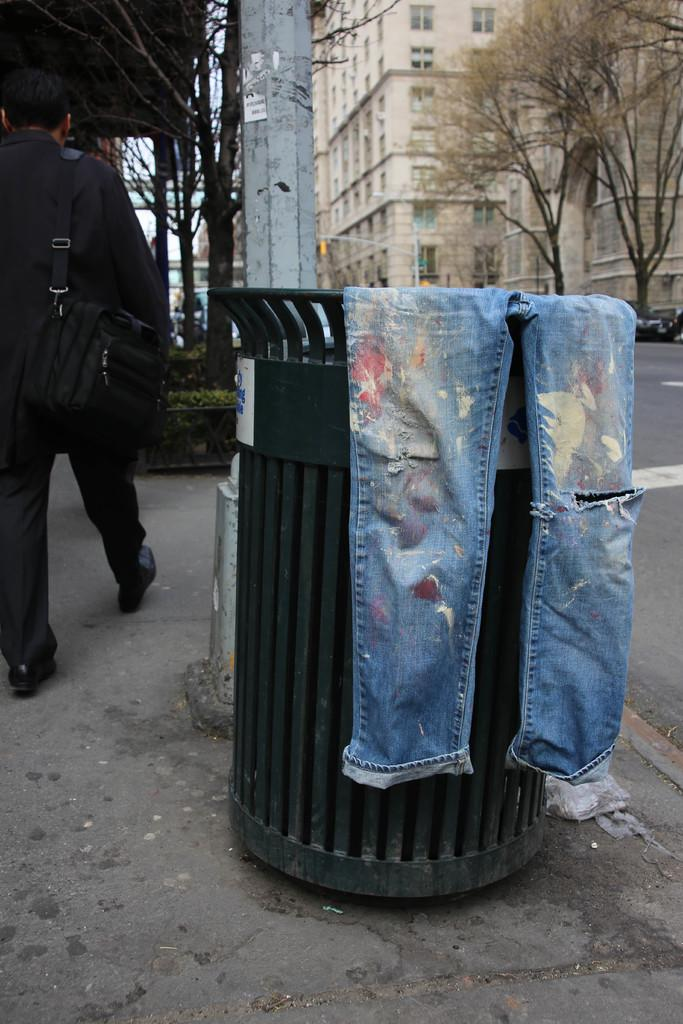What is placed on the trash bin in the image? There is a torn jeans on a trash bin. What is the man on the left side of the image doing? The man is walking at the left side of the image. What is the man wearing? The man is wearing a suit. What is the man carrying? The man is carrying a bag. What can be seen in the background of the image? There are trees, a pole, and buildings in the background of the image. What type of pig can be seen being traded in the image? There is no pig or any indication of trade present in the image. What type of beef is the man eating while walking in the image? There is no beef or any food visible in the image. 